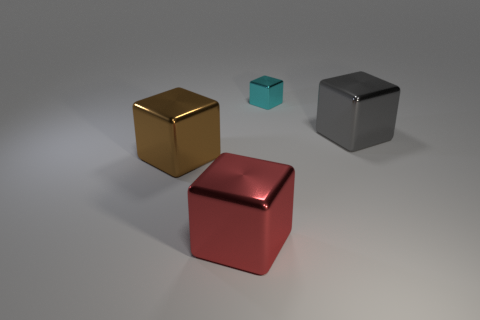Subtract all cyan shiny blocks. How many blocks are left? 3 Subtract all cyan cubes. How many cubes are left? 3 Add 1 metallic cubes. How many objects exist? 5 Subtract all blue blocks. Subtract all yellow cylinders. How many blocks are left? 4 Add 1 cyan shiny blocks. How many cyan shiny blocks exist? 2 Subtract 0 purple blocks. How many objects are left? 4 Subtract all brown metallic objects. Subtract all small blue rubber cylinders. How many objects are left? 3 Add 3 cyan objects. How many cyan objects are left? 4 